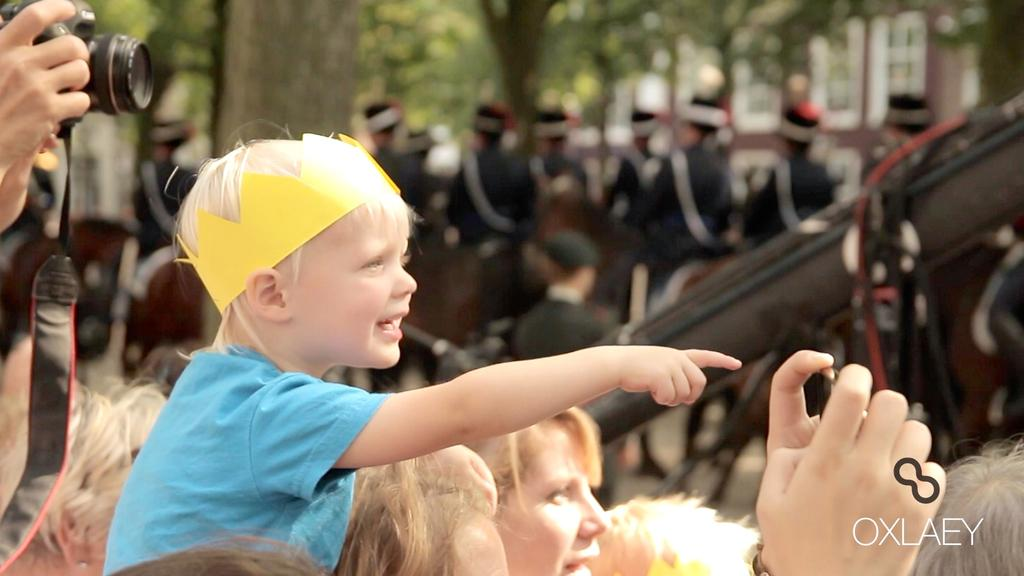How many people are in the image? There are people in the image, but the exact number is not specified. What are some of the people doing in the image? Some of the people are holding objects in the image. What type of natural environment is visible in the image? There are trees in the image, indicating a natural setting. What type of man-made structure is visible in the image? There is a building in the image. What color is the spot on the building in the image? There is no mention of a spot on the building in the image, so it is not possible to determine its color. 